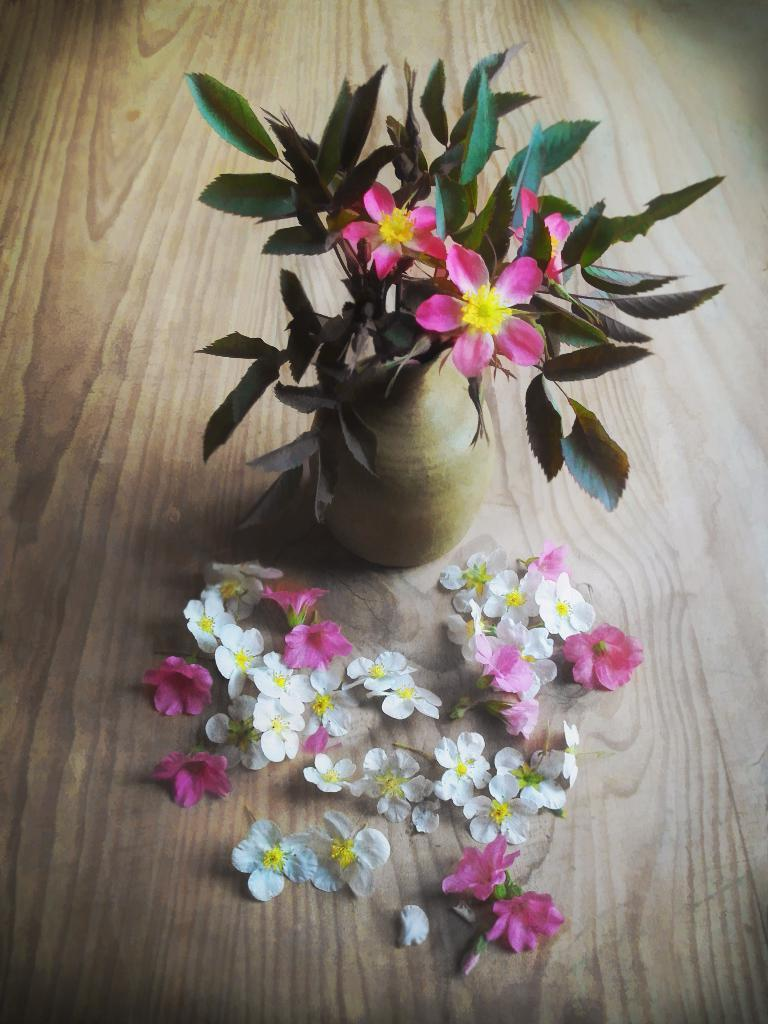What is the person in the image doing with the horse? The person is riding the horse. What type of animal is the person riding? The person is riding a horse. What type of chain is the person using to control the horse in the image? There is no chain visible in the image; the person is riding the horse without any visible means of control. 